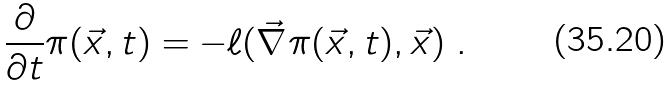<formula> <loc_0><loc_0><loc_500><loc_500>\frac { \partial } { \partial t } \pi ( \vec { x } , t ) = - \ell ( \vec { \nabla } \pi ( \vec { x } , t ) , \vec { x } ) \ .</formula> 